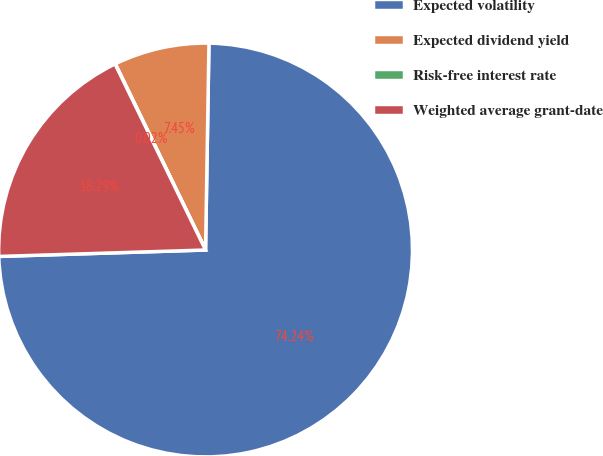<chart> <loc_0><loc_0><loc_500><loc_500><pie_chart><fcel>Expected volatility<fcel>Expected dividend yield<fcel>Risk-free interest rate<fcel>Weighted average grant-date<nl><fcel>74.25%<fcel>7.45%<fcel>0.02%<fcel>18.29%<nl></chart> 